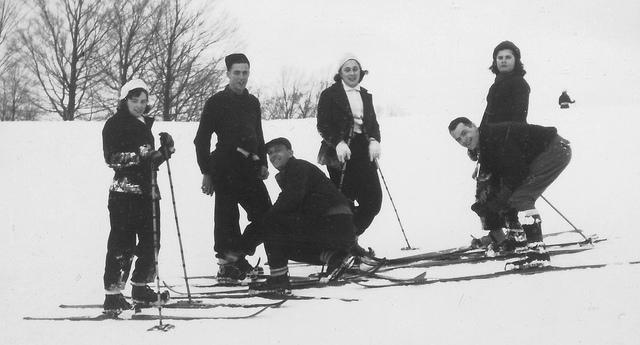Are any of the people children?
Answer briefly. No. Is this an old picture?
Keep it brief. Yes. How many of the women are wearing hats?
Give a very brief answer. 2. 